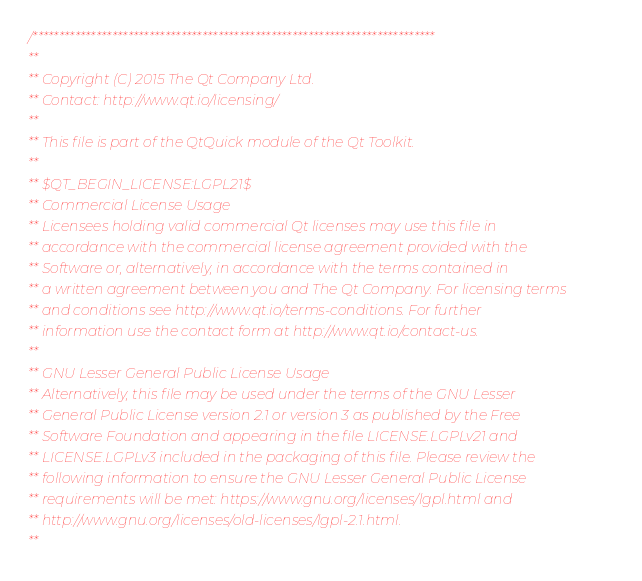<code> <loc_0><loc_0><loc_500><loc_500><_C++_>/****************************************************************************
**
** Copyright (C) 2015 The Qt Company Ltd.
** Contact: http://www.qt.io/licensing/
**
** This file is part of the QtQuick module of the Qt Toolkit.
**
** $QT_BEGIN_LICENSE:LGPL21$
** Commercial License Usage
** Licensees holding valid commercial Qt licenses may use this file in
** accordance with the commercial license agreement provided with the
** Software or, alternatively, in accordance with the terms contained in
** a written agreement between you and The Qt Company. For licensing terms
** and conditions see http://www.qt.io/terms-conditions. For further
** information use the contact form at http://www.qt.io/contact-us.
**
** GNU Lesser General Public License Usage
** Alternatively, this file may be used under the terms of the GNU Lesser
** General Public License version 2.1 or version 3 as published by the Free
** Software Foundation and appearing in the file LICENSE.LGPLv21 and
** LICENSE.LGPLv3 included in the packaging of this file. Please review the
** following information to ensure the GNU Lesser General Public License
** requirements will be met: https://www.gnu.org/licenses/lgpl.html and
** http://www.gnu.org/licenses/old-licenses/lgpl-2.1.html.
**</code> 